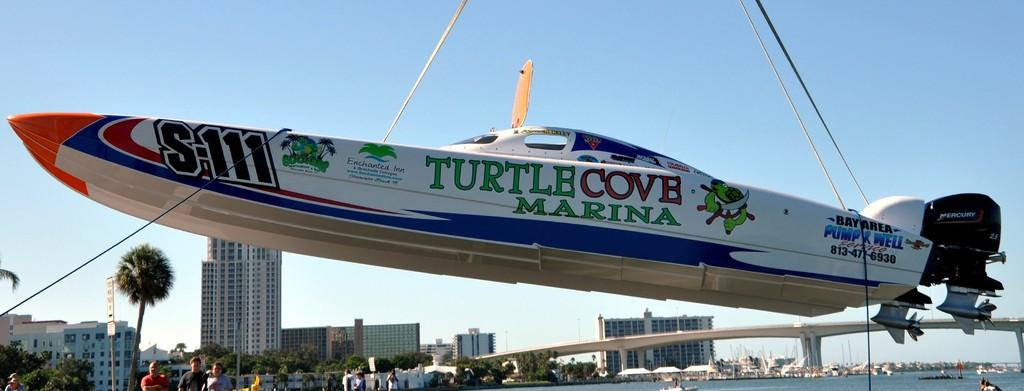<image>
Summarize the visual content of the image. A speed boat with the name Turtle Cove Marina on the side is suspended in the air. 